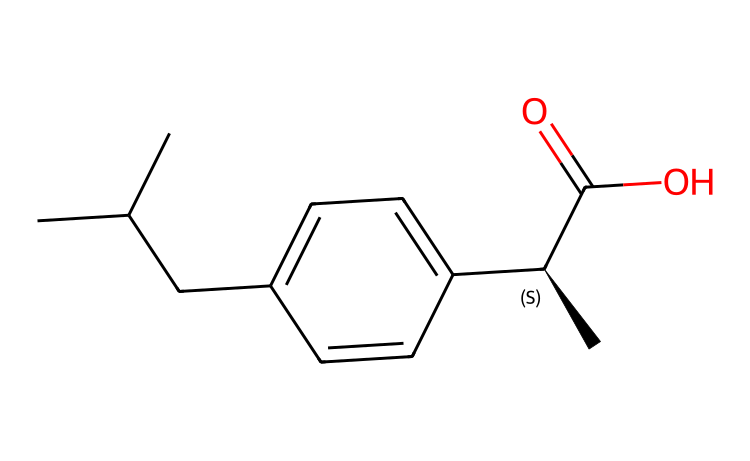What is the molecular formula of ibuprofen? To find the molecular formula, count the number of each type of atom present in the structure. The structure given has 13 carbon (C) atoms, 18 hydrogen (H) atoms, and 2 oxygen (O) atoms. Thus, the formula is C13H18O2.
Answer: C13H18O2 How many rings are present in the structure? The structure does not contain any ring structures; it consists of a linear arrangement of carbon atoms with a benzene ring. Counting all ring types, the answer remains zero.
Answer: 0 What functional group is present in ibuprofen? The presence of the carboxylic acid group can be identified at the end of the molecule. It comprises a -COOH group, which is characteristic of ibuprofen.
Answer: carboxylic acid Is ibuprofen a saturated or unsaturated compound? To determine this, examine the number of double bonds in the structure. The presence of a single carbon-carbon double bond in the benzene ring indicates that the compound is unsaturated.
Answer: unsaturated How many chiral centers are in ibuprofen? By analyzing the structure, there is one carbon atom that is bonded to four different substituents (it is asymmetric). This chiral center is indicated by the stereocenter notation [C@H].
Answer: 1 What is the IUPAC name of ibuprofen? The IUPAC naming convention requires us to consider the longest carbon chain, functional groups, and stereochemistry. Putting together all the information, the IUPAC name is (2RS)-2-(4-(2-methylpropyl)phenyl)propanoic acid.
Answer: (2RS)-2-(4-(2-methylpropyl)phenyl)propanoic acid 